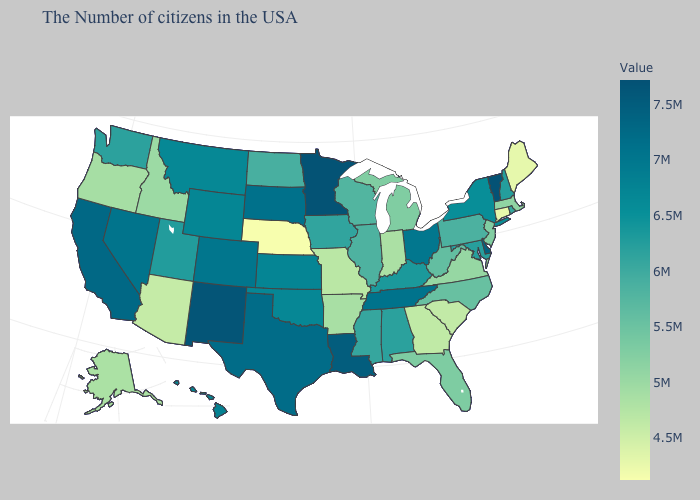Is the legend a continuous bar?
Quick response, please. Yes. Does the map have missing data?
Concise answer only. No. Does West Virginia have a higher value than Vermont?
Keep it brief. No. Which states have the lowest value in the Northeast?
Be succinct. Connecticut. 